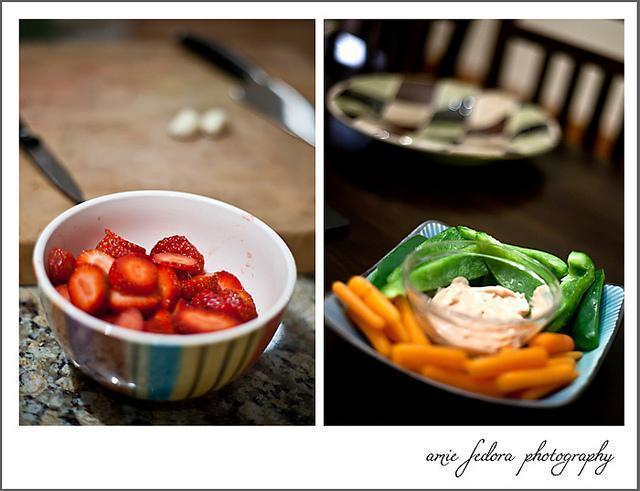What is in the bowl on the left?
Indicate the correct response and explain using: 'Answer: answer
Rationale: rationale.'
Options: Strawberries, lemons, grapes, apples. Answer: strawberries.
Rationale: The bowl has berries. 